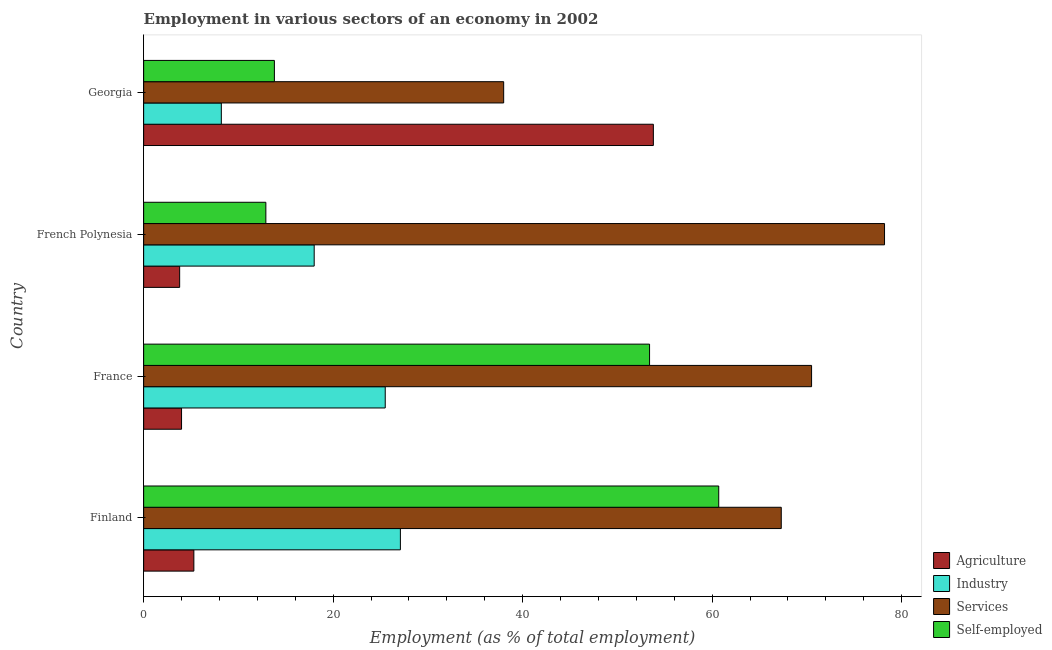How many different coloured bars are there?
Give a very brief answer. 4. How many groups of bars are there?
Give a very brief answer. 4. Are the number of bars per tick equal to the number of legend labels?
Provide a short and direct response. Yes. How many bars are there on the 4th tick from the top?
Provide a succinct answer. 4. What is the label of the 1st group of bars from the top?
Your answer should be very brief. Georgia. Across all countries, what is the maximum percentage of workers in services?
Offer a terse response. 78.2. Across all countries, what is the minimum percentage of self employed workers?
Provide a short and direct response. 12.9. In which country was the percentage of workers in industry minimum?
Ensure brevity in your answer.  Georgia. What is the total percentage of self employed workers in the graph?
Provide a short and direct response. 140.8. What is the difference between the percentage of self employed workers in Finland and the percentage of workers in agriculture in French Polynesia?
Provide a short and direct response. 56.9. What is the difference between the percentage of workers in agriculture and percentage of self employed workers in Georgia?
Provide a short and direct response. 40. In how many countries, is the percentage of self employed workers greater than 20 %?
Give a very brief answer. 2. What is the ratio of the percentage of workers in services in French Polynesia to that in Georgia?
Your answer should be very brief. 2.06. Is the percentage of workers in services in French Polynesia less than that in Georgia?
Provide a succinct answer. No. Is the difference between the percentage of self employed workers in France and Georgia greater than the difference between the percentage of workers in agriculture in France and Georgia?
Ensure brevity in your answer.  Yes. What is the difference between the highest and the second highest percentage of self employed workers?
Your answer should be very brief. 7.3. In how many countries, is the percentage of workers in industry greater than the average percentage of workers in industry taken over all countries?
Give a very brief answer. 2. Is the sum of the percentage of self employed workers in Finland and French Polynesia greater than the maximum percentage of workers in industry across all countries?
Offer a very short reply. Yes. Is it the case that in every country, the sum of the percentage of self employed workers and percentage of workers in services is greater than the sum of percentage of workers in agriculture and percentage of workers in industry?
Offer a very short reply. No. What does the 1st bar from the top in Finland represents?
Offer a very short reply. Self-employed. What does the 1st bar from the bottom in France represents?
Ensure brevity in your answer.  Agriculture. How many bars are there?
Offer a very short reply. 16. How many countries are there in the graph?
Ensure brevity in your answer.  4. Are the values on the major ticks of X-axis written in scientific E-notation?
Provide a succinct answer. No. How are the legend labels stacked?
Your answer should be compact. Vertical. What is the title of the graph?
Provide a short and direct response. Employment in various sectors of an economy in 2002. Does "United Kingdom" appear as one of the legend labels in the graph?
Offer a terse response. No. What is the label or title of the X-axis?
Keep it short and to the point. Employment (as % of total employment). What is the label or title of the Y-axis?
Your answer should be compact. Country. What is the Employment (as % of total employment) of Agriculture in Finland?
Ensure brevity in your answer.  5.3. What is the Employment (as % of total employment) in Industry in Finland?
Make the answer very short. 27.1. What is the Employment (as % of total employment) of Services in Finland?
Offer a very short reply. 67.3. What is the Employment (as % of total employment) of Self-employed in Finland?
Make the answer very short. 60.7. What is the Employment (as % of total employment) of Industry in France?
Your response must be concise. 25.5. What is the Employment (as % of total employment) of Services in France?
Offer a terse response. 70.5. What is the Employment (as % of total employment) of Self-employed in France?
Keep it short and to the point. 53.4. What is the Employment (as % of total employment) of Agriculture in French Polynesia?
Offer a terse response. 3.8. What is the Employment (as % of total employment) in Services in French Polynesia?
Your response must be concise. 78.2. What is the Employment (as % of total employment) of Self-employed in French Polynesia?
Provide a short and direct response. 12.9. What is the Employment (as % of total employment) of Agriculture in Georgia?
Your answer should be compact. 53.8. What is the Employment (as % of total employment) of Industry in Georgia?
Give a very brief answer. 8.2. What is the Employment (as % of total employment) in Self-employed in Georgia?
Give a very brief answer. 13.8. Across all countries, what is the maximum Employment (as % of total employment) of Agriculture?
Make the answer very short. 53.8. Across all countries, what is the maximum Employment (as % of total employment) of Industry?
Make the answer very short. 27.1. Across all countries, what is the maximum Employment (as % of total employment) of Services?
Keep it short and to the point. 78.2. Across all countries, what is the maximum Employment (as % of total employment) of Self-employed?
Offer a very short reply. 60.7. Across all countries, what is the minimum Employment (as % of total employment) of Agriculture?
Make the answer very short. 3.8. Across all countries, what is the minimum Employment (as % of total employment) in Industry?
Ensure brevity in your answer.  8.2. Across all countries, what is the minimum Employment (as % of total employment) in Services?
Give a very brief answer. 38. Across all countries, what is the minimum Employment (as % of total employment) of Self-employed?
Offer a very short reply. 12.9. What is the total Employment (as % of total employment) of Agriculture in the graph?
Offer a very short reply. 66.9. What is the total Employment (as % of total employment) in Industry in the graph?
Keep it short and to the point. 78.8. What is the total Employment (as % of total employment) in Services in the graph?
Offer a terse response. 254. What is the total Employment (as % of total employment) of Self-employed in the graph?
Your response must be concise. 140.8. What is the difference between the Employment (as % of total employment) of Agriculture in Finland and that in France?
Ensure brevity in your answer.  1.3. What is the difference between the Employment (as % of total employment) in Industry in Finland and that in France?
Your answer should be very brief. 1.6. What is the difference between the Employment (as % of total employment) of Self-employed in Finland and that in France?
Give a very brief answer. 7.3. What is the difference between the Employment (as % of total employment) in Self-employed in Finland and that in French Polynesia?
Your answer should be very brief. 47.8. What is the difference between the Employment (as % of total employment) in Agriculture in Finland and that in Georgia?
Your answer should be very brief. -48.5. What is the difference between the Employment (as % of total employment) of Services in Finland and that in Georgia?
Your answer should be compact. 29.3. What is the difference between the Employment (as % of total employment) in Self-employed in Finland and that in Georgia?
Your answer should be very brief. 46.9. What is the difference between the Employment (as % of total employment) in Agriculture in France and that in French Polynesia?
Ensure brevity in your answer.  0.2. What is the difference between the Employment (as % of total employment) in Industry in France and that in French Polynesia?
Provide a short and direct response. 7.5. What is the difference between the Employment (as % of total employment) in Self-employed in France and that in French Polynesia?
Provide a succinct answer. 40.5. What is the difference between the Employment (as % of total employment) of Agriculture in France and that in Georgia?
Your answer should be compact. -49.8. What is the difference between the Employment (as % of total employment) in Industry in France and that in Georgia?
Ensure brevity in your answer.  17.3. What is the difference between the Employment (as % of total employment) of Services in France and that in Georgia?
Give a very brief answer. 32.5. What is the difference between the Employment (as % of total employment) in Self-employed in France and that in Georgia?
Give a very brief answer. 39.6. What is the difference between the Employment (as % of total employment) of Services in French Polynesia and that in Georgia?
Offer a very short reply. 40.2. What is the difference between the Employment (as % of total employment) of Agriculture in Finland and the Employment (as % of total employment) of Industry in France?
Make the answer very short. -20.2. What is the difference between the Employment (as % of total employment) of Agriculture in Finland and the Employment (as % of total employment) of Services in France?
Provide a short and direct response. -65.2. What is the difference between the Employment (as % of total employment) of Agriculture in Finland and the Employment (as % of total employment) of Self-employed in France?
Give a very brief answer. -48.1. What is the difference between the Employment (as % of total employment) of Industry in Finland and the Employment (as % of total employment) of Services in France?
Offer a very short reply. -43.4. What is the difference between the Employment (as % of total employment) in Industry in Finland and the Employment (as % of total employment) in Self-employed in France?
Make the answer very short. -26.3. What is the difference between the Employment (as % of total employment) of Services in Finland and the Employment (as % of total employment) of Self-employed in France?
Keep it short and to the point. 13.9. What is the difference between the Employment (as % of total employment) in Agriculture in Finland and the Employment (as % of total employment) in Services in French Polynesia?
Keep it short and to the point. -72.9. What is the difference between the Employment (as % of total employment) in Industry in Finland and the Employment (as % of total employment) in Services in French Polynesia?
Your response must be concise. -51.1. What is the difference between the Employment (as % of total employment) in Services in Finland and the Employment (as % of total employment) in Self-employed in French Polynesia?
Offer a terse response. 54.4. What is the difference between the Employment (as % of total employment) in Agriculture in Finland and the Employment (as % of total employment) in Services in Georgia?
Ensure brevity in your answer.  -32.7. What is the difference between the Employment (as % of total employment) in Services in Finland and the Employment (as % of total employment) in Self-employed in Georgia?
Your answer should be compact. 53.5. What is the difference between the Employment (as % of total employment) of Agriculture in France and the Employment (as % of total employment) of Industry in French Polynesia?
Give a very brief answer. -14. What is the difference between the Employment (as % of total employment) in Agriculture in France and the Employment (as % of total employment) in Services in French Polynesia?
Keep it short and to the point. -74.2. What is the difference between the Employment (as % of total employment) in Agriculture in France and the Employment (as % of total employment) in Self-employed in French Polynesia?
Your response must be concise. -8.9. What is the difference between the Employment (as % of total employment) of Industry in France and the Employment (as % of total employment) of Services in French Polynesia?
Your answer should be compact. -52.7. What is the difference between the Employment (as % of total employment) in Industry in France and the Employment (as % of total employment) in Self-employed in French Polynesia?
Make the answer very short. 12.6. What is the difference between the Employment (as % of total employment) of Services in France and the Employment (as % of total employment) of Self-employed in French Polynesia?
Provide a short and direct response. 57.6. What is the difference between the Employment (as % of total employment) of Agriculture in France and the Employment (as % of total employment) of Services in Georgia?
Give a very brief answer. -34. What is the difference between the Employment (as % of total employment) in Agriculture in France and the Employment (as % of total employment) in Self-employed in Georgia?
Your answer should be compact. -9.8. What is the difference between the Employment (as % of total employment) in Industry in France and the Employment (as % of total employment) in Services in Georgia?
Offer a very short reply. -12.5. What is the difference between the Employment (as % of total employment) of Services in France and the Employment (as % of total employment) of Self-employed in Georgia?
Offer a very short reply. 56.7. What is the difference between the Employment (as % of total employment) in Agriculture in French Polynesia and the Employment (as % of total employment) in Services in Georgia?
Offer a terse response. -34.2. What is the difference between the Employment (as % of total employment) of Industry in French Polynesia and the Employment (as % of total employment) of Services in Georgia?
Your answer should be compact. -20. What is the difference between the Employment (as % of total employment) in Services in French Polynesia and the Employment (as % of total employment) in Self-employed in Georgia?
Offer a terse response. 64.4. What is the average Employment (as % of total employment) in Agriculture per country?
Your answer should be very brief. 16.73. What is the average Employment (as % of total employment) of Industry per country?
Give a very brief answer. 19.7. What is the average Employment (as % of total employment) in Services per country?
Your answer should be very brief. 63.5. What is the average Employment (as % of total employment) in Self-employed per country?
Give a very brief answer. 35.2. What is the difference between the Employment (as % of total employment) of Agriculture and Employment (as % of total employment) of Industry in Finland?
Offer a terse response. -21.8. What is the difference between the Employment (as % of total employment) of Agriculture and Employment (as % of total employment) of Services in Finland?
Make the answer very short. -62. What is the difference between the Employment (as % of total employment) of Agriculture and Employment (as % of total employment) of Self-employed in Finland?
Your response must be concise. -55.4. What is the difference between the Employment (as % of total employment) of Industry and Employment (as % of total employment) of Services in Finland?
Your response must be concise. -40.2. What is the difference between the Employment (as % of total employment) in Industry and Employment (as % of total employment) in Self-employed in Finland?
Ensure brevity in your answer.  -33.6. What is the difference between the Employment (as % of total employment) in Agriculture and Employment (as % of total employment) in Industry in France?
Your response must be concise. -21.5. What is the difference between the Employment (as % of total employment) in Agriculture and Employment (as % of total employment) in Services in France?
Offer a terse response. -66.5. What is the difference between the Employment (as % of total employment) of Agriculture and Employment (as % of total employment) of Self-employed in France?
Make the answer very short. -49.4. What is the difference between the Employment (as % of total employment) of Industry and Employment (as % of total employment) of Services in France?
Offer a terse response. -45. What is the difference between the Employment (as % of total employment) of Industry and Employment (as % of total employment) of Self-employed in France?
Your answer should be compact. -27.9. What is the difference between the Employment (as % of total employment) of Services and Employment (as % of total employment) of Self-employed in France?
Keep it short and to the point. 17.1. What is the difference between the Employment (as % of total employment) in Agriculture and Employment (as % of total employment) in Industry in French Polynesia?
Offer a terse response. -14.2. What is the difference between the Employment (as % of total employment) in Agriculture and Employment (as % of total employment) in Services in French Polynesia?
Your answer should be very brief. -74.4. What is the difference between the Employment (as % of total employment) of Agriculture and Employment (as % of total employment) of Self-employed in French Polynesia?
Offer a terse response. -9.1. What is the difference between the Employment (as % of total employment) of Industry and Employment (as % of total employment) of Services in French Polynesia?
Your response must be concise. -60.2. What is the difference between the Employment (as % of total employment) in Services and Employment (as % of total employment) in Self-employed in French Polynesia?
Make the answer very short. 65.3. What is the difference between the Employment (as % of total employment) of Agriculture and Employment (as % of total employment) of Industry in Georgia?
Give a very brief answer. 45.6. What is the difference between the Employment (as % of total employment) of Industry and Employment (as % of total employment) of Services in Georgia?
Keep it short and to the point. -29.8. What is the difference between the Employment (as % of total employment) in Services and Employment (as % of total employment) in Self-employed in Georgia?
Offer a terse response. 24.2. What is the ratio of the Employment (as % of total employment) in Agriculture in Finland to that in France?
Keep it short and to the point. 1.32. What is the ratio of the Employment (as % of total employment) of Industry in Finland to that in France?
Your response must be concise. 1.06. What is the ratio of the Employment (as % of total employment) in Services in Finland to that in France?
Keep it short and to the point. 0.95. What is the ratio of the Employment (as % of total employment) in Self-employed in Finland to that in France?
Make the answer very short. 1.14. What is the ratio of the Employment (as % of total employment) in Agriculture in Finland to that in French Polynesia?
Your answer should be compact. 1.39. What is the ratio of the Employment (as % of total employment) in Industry in Finland to that in French Polynesia?
Your answer should be very brief. 1.51. What is the ratio of the Employment (as % of total employment) of Services in Finland to that in French Polynesia?
Your response must be concise. 0.86. What is the ratio of the Employment (as % of total employment) of Self-employed in Finland to that in French Polynesia?
Offer a terse response. 4.71. What is the ratio of the Employment (as % of total employment) of Agriculture in Finland to that in Georgia?
Your answer should be very brief. 0.1. What is the ratio of the Employment (as % of total employment) of Industry in Finland to that in Georgia?
Provide a short and direct response. 3.3. What is the ratio of the Employment (as % of total employment) in Services in Finland to that in Georgia?
Ensure brevity in your answer.  1.77. What is the ratio of the Employment (as % of total employment) of Self-employed in Finland to that in Georgia?
Make the answer very short. 4.4. What is the ratio of the Employment (as % of total employment) of Agriculture in France to that in French Polynesia?
Provide a short and direct response. 1.05. What is the ratio of the Employment (as % of total employment) of Industry in France to that in French Polynesia?
Your answer should be very brief. 1.42. What is the ratio of the Employment (as % of total employment) of Services in France to that in French Polynesia?
Offer a very short reply. 0.9. What is the ratio of the Employment (as % of total employment) of Self-employed in France to that in French Polynesia?
Keep it short and to the point. 4.14. What is the ratio of the Employment (as % of total employment) of Agriculture in France to that in Georgia?
Offer a very short reply. 0.07. What is the ratio of the Employment (as % of total employment) of Industry in France to that in Georgia?
Ensure brevity in your answer.  3.11. What is the ratio of the Employment (as % of total employment) of Services in France to that in Georgia?
Offer a very short reply. 1.86. What is the ratio of the Employment (as % of total employment) of Self-employed in France to that in Georgia?
Offer a very short reply. 3.87. What is the ratio of the Employment (as % of total employment) in Agriculture in French Polynesia to that in Georgia?
Your response must be concise. 0.07. What is the ratio of the Employment (as % of total employment) of Industry in French Polynesia to that in Georgia?
Provide a succinct answer. 2.2. What is the ratio of the Employment (as % of total employment) of Services in French Polynesia to that in Georgia?
Offer a terse response. 2.06. What is the ratio of the Employment (as % of total employment) in Self-employed in French Polynesia to that in Georgia?
Your answer should be very brief. 0.93. What is the difference between the highest and the second highest Employment (as % of total employment) in Agriculture?
Make the answer very short. 48.5. What is the difference between the highest and the second highest Employment (as % of total employment) in Services?
Provide a short and direct response. 7.7. What is the difference between the highest and the lowest Employment (as % of total employment) of Industry?
Keep it short and to the point. 18.9. What is the difference between the highest and the lowest Employment (as % of total employment) in Services?
Your answer should be compact. 40.2. What is the difference between the highest and the lowest Employment (as % of total employment) in Self-employed?
Your answer should be very brief. 47.8. 